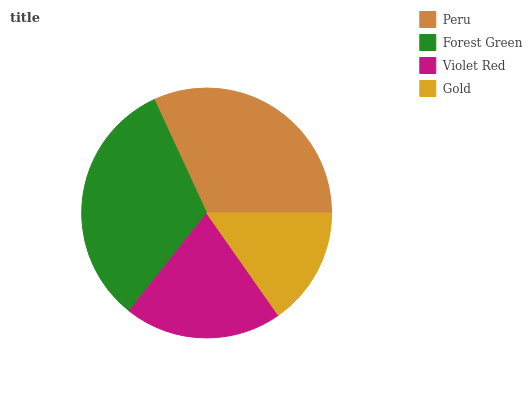Is Gold the minimum?
Answer yes or no. Yes. Is Forest Green the maximum?
Answer yes or no. Yes. Is Violet Red the minimum?
Answer yes or no. No. Is Violet Red the maximum?
Answer yes or no. No. Is Forest Green greater than Violet Red?
Answer yes or no. Yes. Is Violet Red less than Forest Green?
Answer yes or no. Yes. Is Violet Red greater than Forest Green?
Answer yes or no. No. Is Forest Green less than Violet Red?
Answer yes or no. No. Is Peru the high median?
Answer yes or no. Yes. Is Violet Red the low median?
Answer yes or no. Yes. Is Forest Green the high median?
Answer yes or no. No. Is Forest Green the low median?
Answer yes or no. No. 